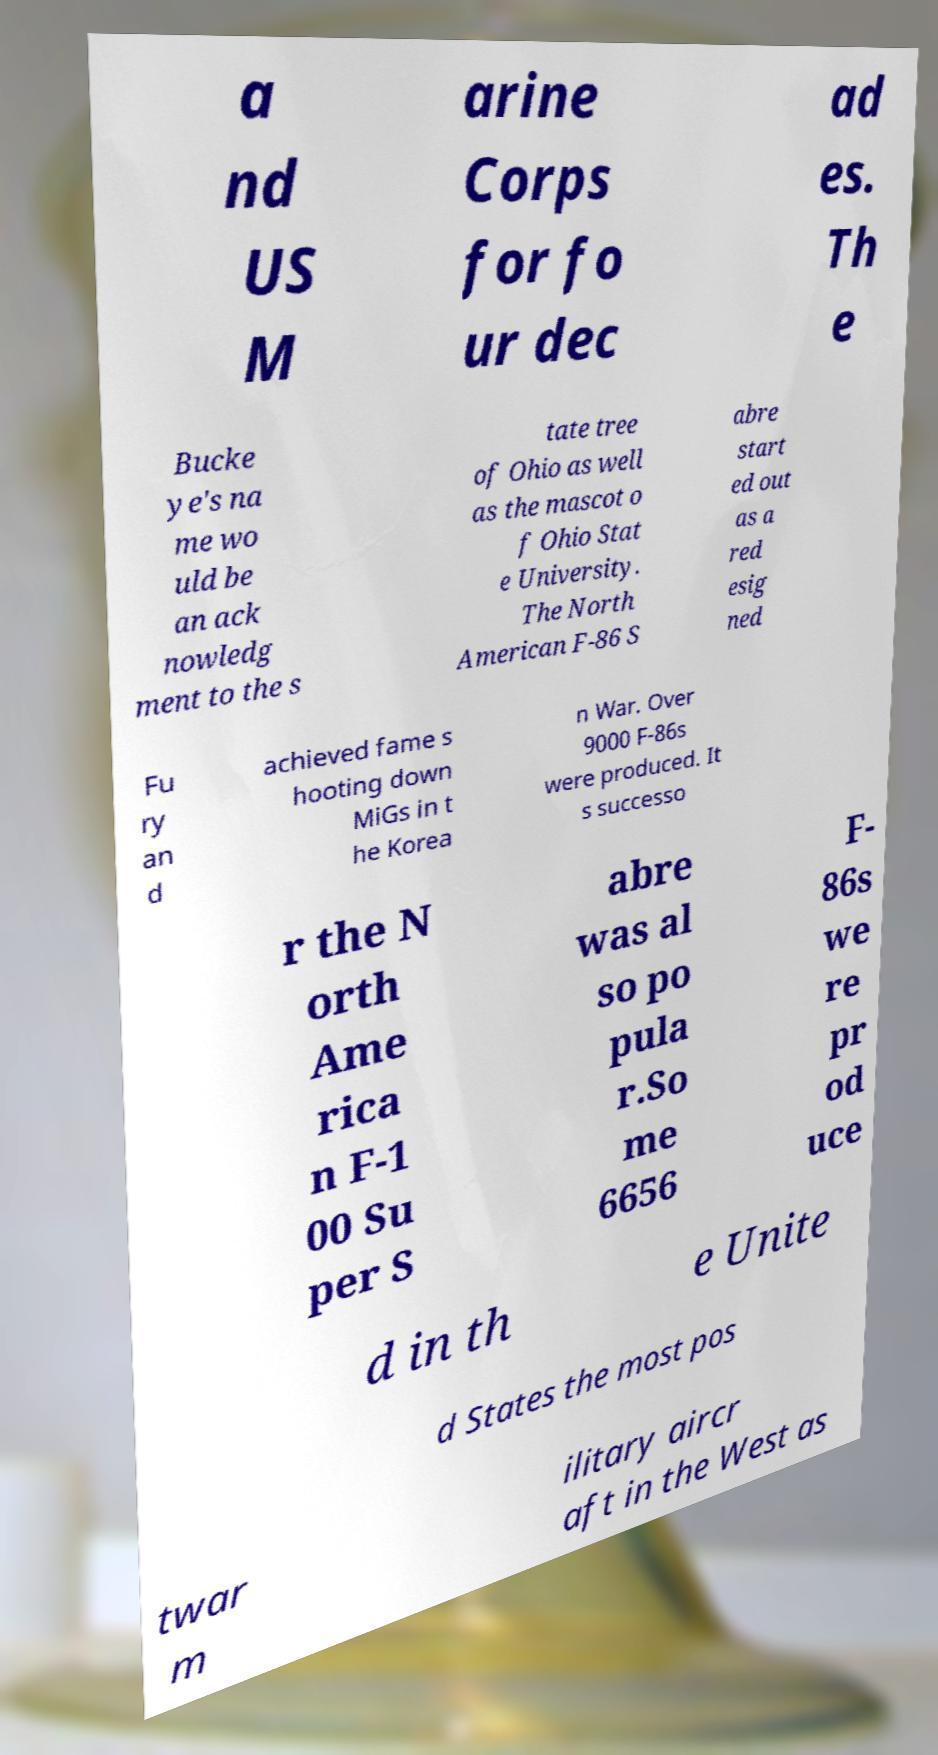There's text embedded in this image that I need extracted. Can you transcribe it verbatim? a nd US M arine Corps for fo ur dec ad es. Th e Bucke ye's na me wo uld be an ack nowledg ment to the s tate tree of Ohio as well as the mascot o f Ohio Stat e University. The North American F-86 S abre start ed out as a red esig ned Fu ry an d achieved fame s hooting down MiGs in t he Korea n War. Over 9000 F-86s were produced. It s successo r the N orth Ame rica n F-1 00 Su per S abre was al so po pula r.So me 6656 F- 86s we re pr od uce d in th e Unite d States the most pos twar m ilitary aircr aft in the West as 